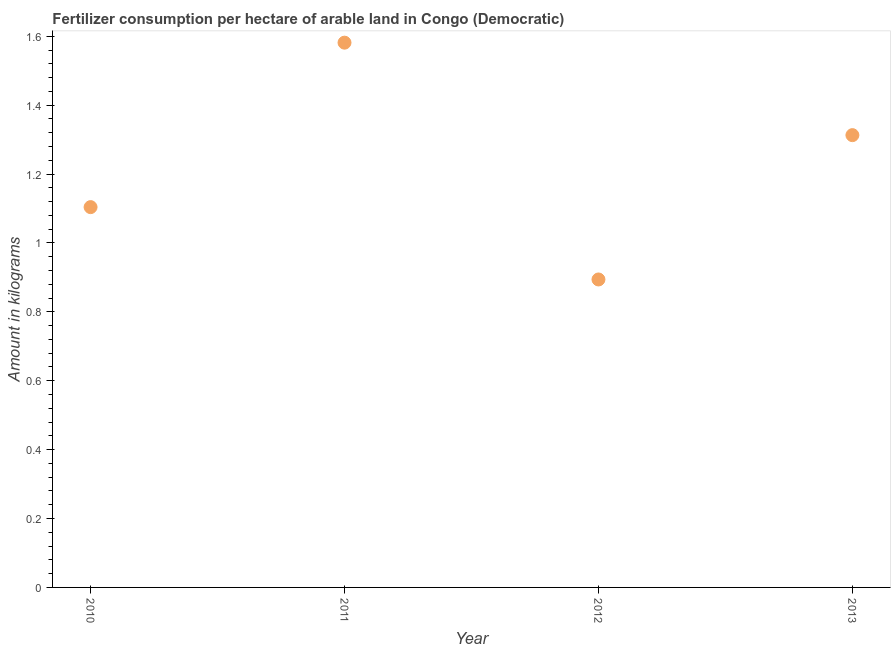What is the amount of fertilizer consumption in 2011?
Offer a very short reply. 1.58. Across all years, what is the maximum amount of fertilizer consumption?
Offer a terse response. 1.58. Across all years, what is the minimum amount of fertilizer consumption?
Offer a terse response. 0.89. What is the sum of the amount of fertilizer consumption?
Provide a short and direct response. 4.89. What is the difference between the amount of fertilizer consumption in 2011 and 2012?
Give a very brief answer. 0.69. What is the average amount of fertilizer consumption per year?
Offer a terse response. 1.22. What is the median amount of fertilizer consumption?
Offer a very short reply. 1.21. Do a majority of the years between 2013 and 2012 (inclusive) have amount of fertilizer consumption greater than 1 kg?
Give a very brief answer. No. What is the ratio of the amount of fertilizer consumption in 2011 to that in 2012?
Provide a succinct answer. 1.77. Is the amount of fertilizer consumption in 2010 less than that in 2012?
Provide a short and direct response. No. Is the difference between the amount of fertilizer consumption in 2011 and 2012 greater than the difference between any two years?
Offer a very short reply. Yes. What is the difference between the highest and the second highest amount of fertilizer consumption?
Offer a terse response. 0.27. What is the difference between the highest and the lowest amount of fertilizer consumption?
Ensure brevity in your answer.  0.69. What is the difference between two consecutive major ticks on the Y-axis?
Make the answer very short. 0.2. What is the title of the graph?
Offer a terse response. Fertilizer consumption per hectare of arable land in Congo (Democratic) . What is the label or title of the Y-axis?
Your response must be concise. Amount in kilograms. What is the Amount in kilograms in 2010?
Ensure brevity in your answer.  1.1. What is the Amount in kilograms in 2011?
Keep it short and to the point. 1.58. What is the Amount in kilograms in 2012?
Offer a terse response. 0.89. What is the Amount in kilograms in 2013?
Your response must be concise. 1.31. What is the difference between the Amount in kilograms in 2010 and 2011?
Provide a short and direct response. -0.48. What is the difference between the Amount in kilograms in 2010 and 2012?
Keep it short and to the point. 0.21. What is the difference between the Amount in kilograms in 2010 and 2013?
Your answer should be compact. -0.21. What is the difference between the Amount in kilograms in 2011 and 2012?
Offer a very short reply. 0.69. What is the difference between the Amount in kilograms in 2011 and 2013?
Provide a succinct answer. 0.27. What is the difference between the Amount in kilograms in 2012 and 2013?
Offer a very short reply. -0.42. What is the ratio of the Amount in kilograms in 2010 to that in 2011?
Give a very brief answer. 0.7. What is the ratio of the Amount in kilograms in 2010 to that in 2012?
Offer a very short reply. 1.24. What is the ratio of the Amount in kilograms in 2010 to that in 2013?
Offer a terse response. 0.84. What is the ratio of the Amount in kilograms in 2011 to that in 2012?
Your answer should be compact. 1.77. What is the ratio of the Amount in kilograms in 2011 to that in 2013?
Give a very brief answer. 1.2. What is the ratio of the Amount in kilograms in 2012 to that in 2013?
Keep it short and to the point. 0.68. 